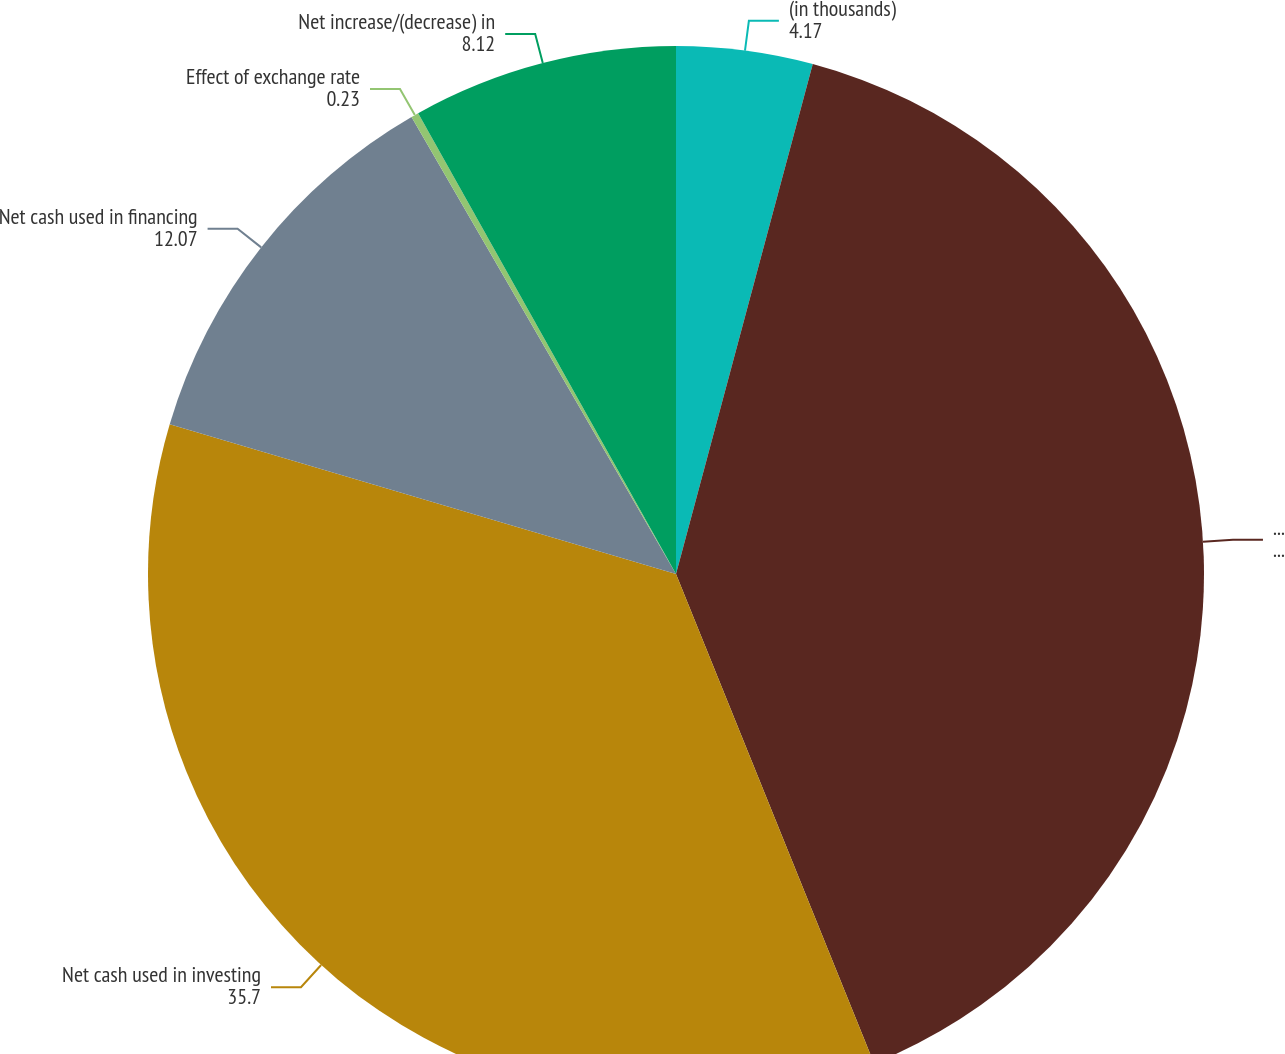Convert chart to OTSL. <chart><loc_0><loc_0><loc_500><loc_500><pie_chart><fcel>(in thousands)<fcel>Net cash provided by operating<fcel>Net cash used in investing<fcel>Net cash used in financing<fcel>Effect of exchange rate<fcel>Net increase/(decrease) in<nl><fcel>4.17%<fcel>39.71%<fcel>35.7%<fcel>12.07%<fcel>0.23%<fcel>8.12%<nl></chart> 